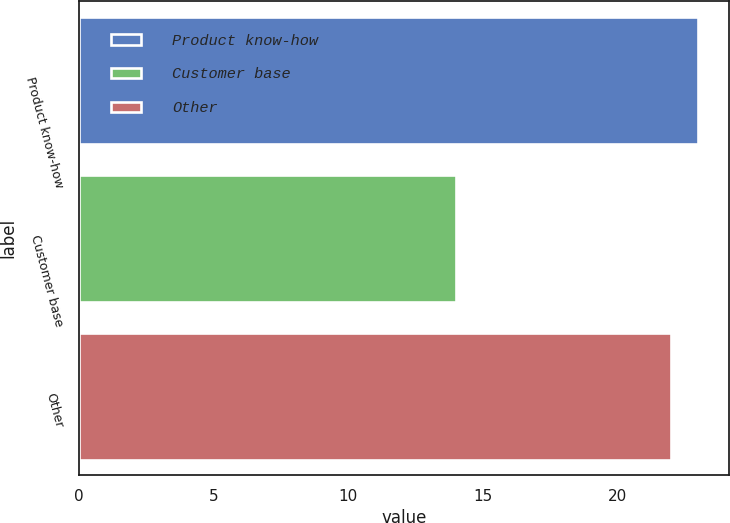Convert chart. <chart><loc_0><loc_0><loc_500><loc_500><bar_chart><fcel>Product know-how<fcel>Customer base<fcel>Other<nl><fcel>23<fcel>14<fcel>22<nl></chart> 